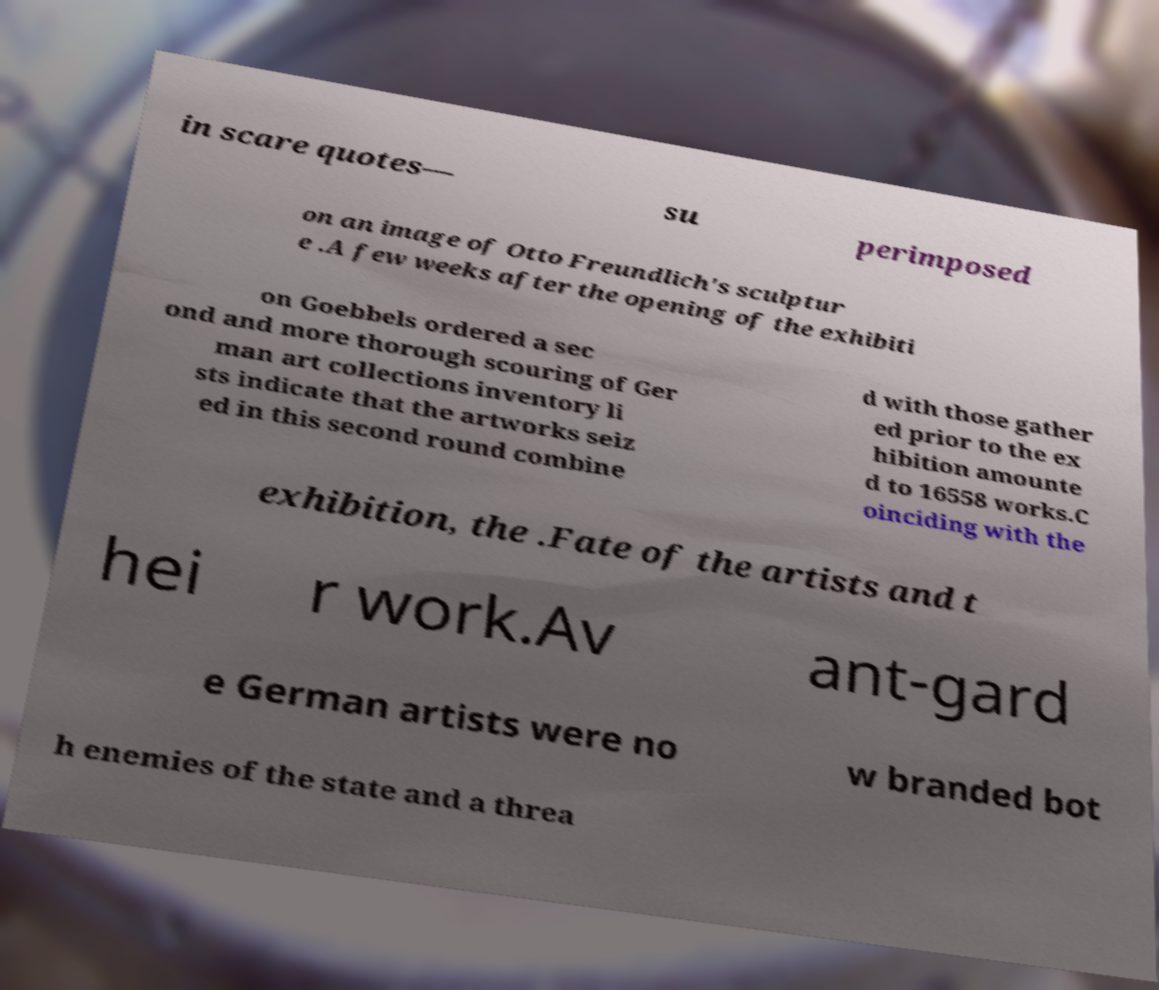Could you assist in decoding the text presented in this image and type it out clearly? in scare quotes— su perimposed on an image of Otto Freundlich's sculptur e .A few weeks after the opening of the exhibiti on Goebbels ordered a sec ond and more thorough scouring of Ger man art collections inventory li sts indicate that the artworks seiz ed in this second round combine d with those gather ed prior to the ex hibition amounte d to 16558 works.C oinciding with the exhibition, the .Fate of the artists and t hei r work.Av ant-gard e German artists were no w branded bot h enemies of the state and a threa 